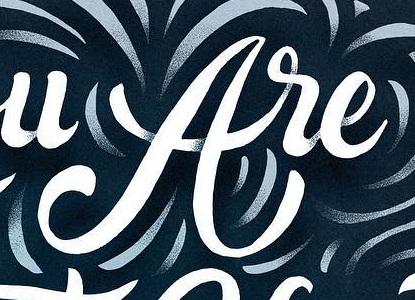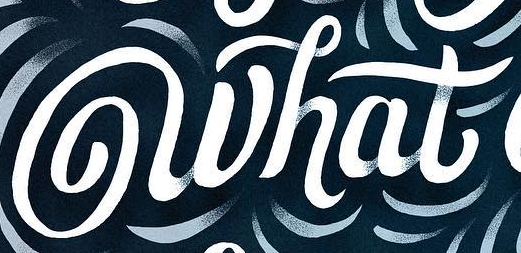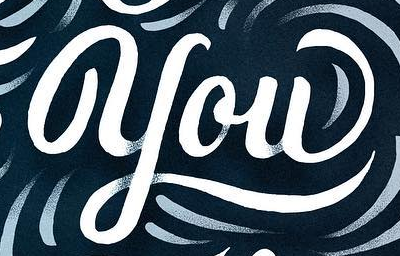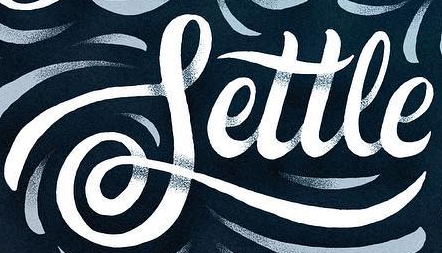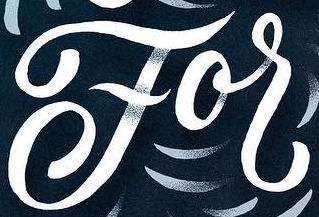What text appears in these images from left to right, separated by a semicolon? are; what; you; Settle; For 